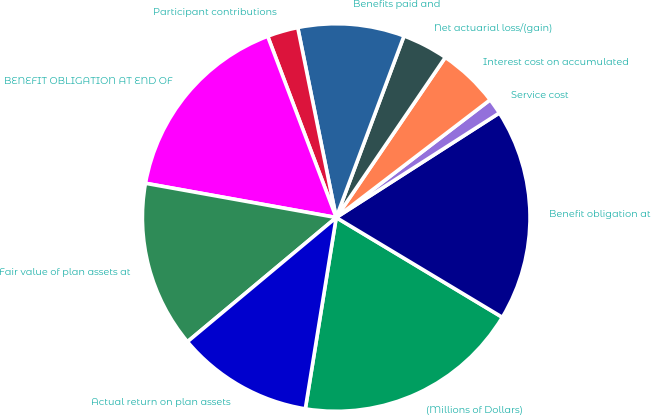<chart> <loc_0><loc_0><loc_500><loc_500><pie_chart><fcel>(Millions of Dollars)<fcel>Benefit obligation at<fcel>Service cost<fcel>Interest cost on accumulated<fcel>Net actuarial loss/(gain)<fcel>Benefits paid and<fcel>Participant contributions<fcel>BENEFIT OBLIGATION AT END OF<fcel>Fair value of plan assets at<fcel>Actual return on plan assets<nl><fcel>18.94%<fcel>17.68%<fcel>1.32%<fcel>5.09%<fcel>3.83%<fcel>8.87%<fcel>2.57%<fcel>16.42%<fcel>13.9%<fcel>11.38%<nl></chart> 